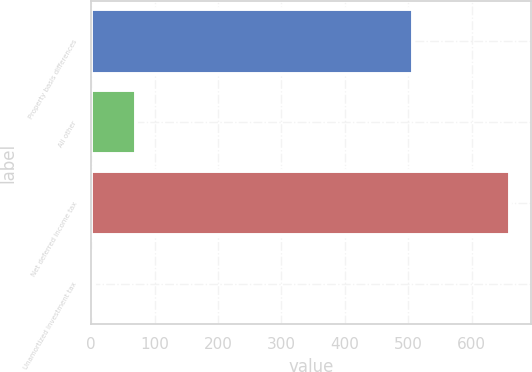<chart> <loc_0><loc_0><loc_500><loc_500><bar_chart><fcel>Property basis differences<fcel>All other<fcel>Net deferred income tax<fcel>Unamortized investment tax<nl><fcel>508<fcel>70.5<fcel>660<fcel>5<nl></chart> 